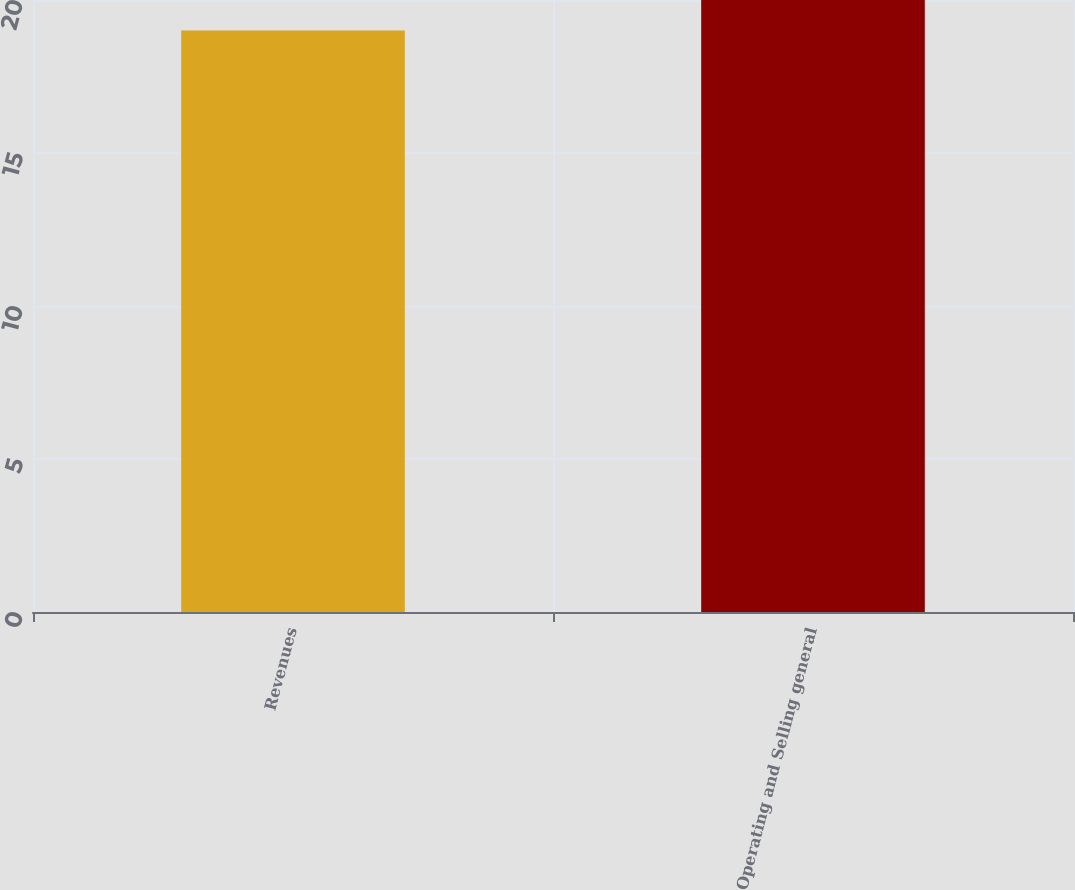Convert chart to OTSL. <chart><loc_0><loc_0><loc_500><loc_500><bar_chart><fcel>Revenues<fcel>Operating and Selling general<nl><fcel>19<fcel>20<nl></chart> 